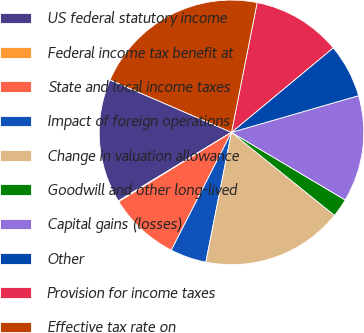Convert chart to OTSL. <chart><loc_0><loc_0><loc_500><loc_500><pie_chart><fcel>US federal statutory income<fcel>Federal income tax benefit at<fcel>State and local income taxes<fcel>Impact of foreign operations<fcel>Change in valuation allowance<fcel>Goodwill and other long-lived<fcel>Capital gains (losses)<fcel>Other<fcel>Provision for income taxes<fcel>Effective tax rate on<nl><fcel>15.16%<fcel>0.1%<fcel>8.71%<fcel>4.41%<fcel>17.31%<fcel>2.26%<fcel>13.01%<fcel>6.56%<fcel>10.86%<fcel>21.62%<nl></chart> 